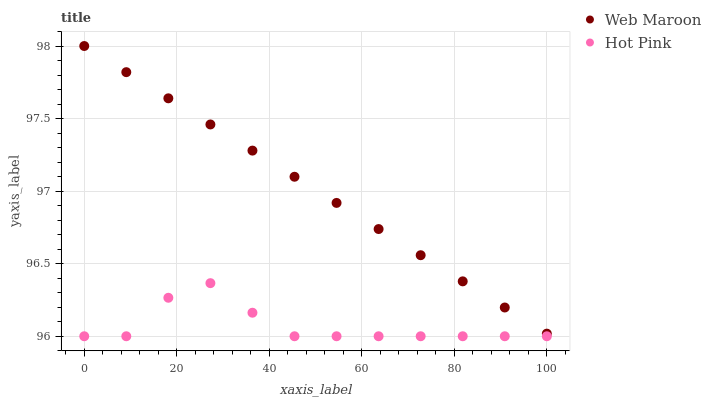Does Hot Pink have the minimum area under the curve?
Answer yes or no. Yes. Does Web Maroon have the maximum area under the curve?
Answer yes or no. Yes. Does Web Maroon have the minimum area under the curve?
Answer yes or no. No. Is Web Maroon the smoothest?
Answer yes or no. Yes. Is Hot Pink the roughest?
Answer yes or no. Yes. Is Web Maroon the roughest?
Answer yes or no. No. Does Hot Pink have the lowest value?
Answer yes or no. Yes. Does Web Maroon have the lowest value?
Answer yes or no. No. Does Web Maroon have the highest value?
Answer yes or no. Yes. Is Hot Pink less than Web Maroon?
Answer yes or no. Yes. Is Web Maroon greater than Hot Pink?
Answer yes or no. Yes. Does Hot Pink intersect Web Maroon?
Answer yes or no. No. 